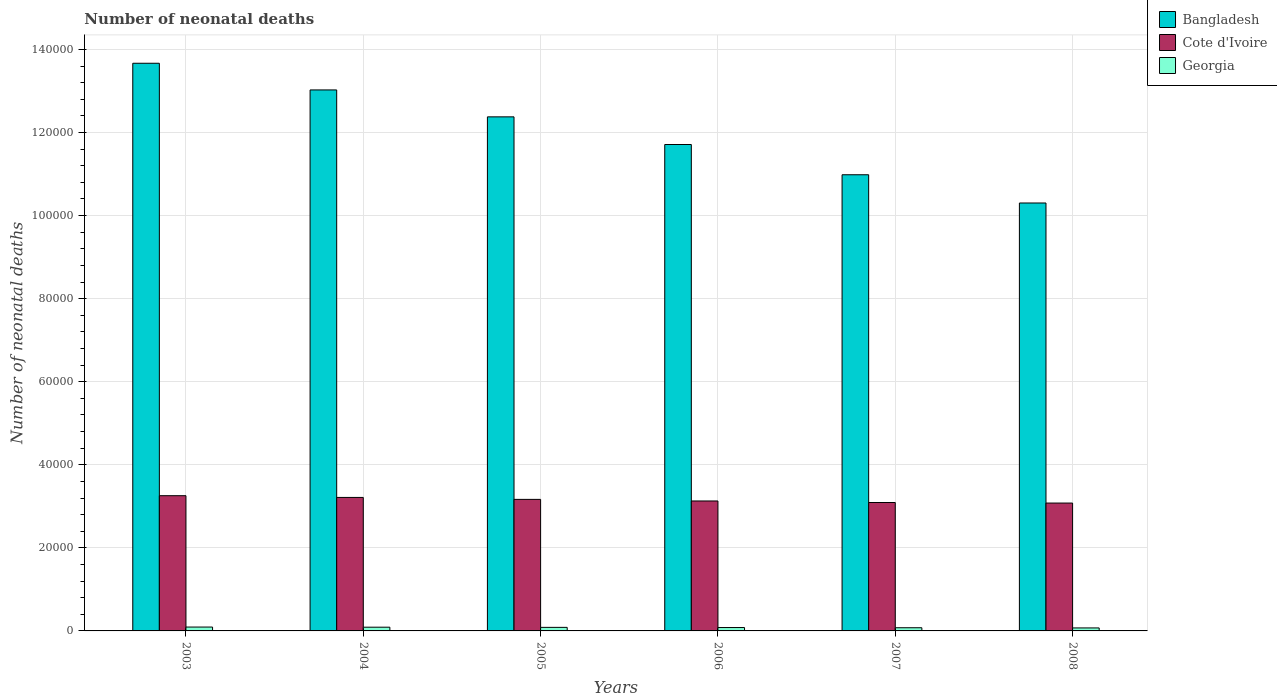How many groups of bars are there?
Provide a short and direct response. 6. Are the number of bars on each tick of the X-axis equal?
Offer a terse response. Yes. How many bars are there on the 6th tick from the left?
Make the answer very short. 3. How many bars are there on the 4th tick from the right?
Offer a terse response. 3. In how many cases, is the number of bars for a given year not equal to the number of legend labels?
Make the answer very short. 0. What is the number of neonatal deaths in in Georgia in 2006?
Your answer should be compact. 814. Across all years, what is the maximum number of neonatal deaths in in Bangladesh?
Your answer should be compact. 1.37e+05. Across all years, what is the minimum number of neonatal deaths in in Georgia?
Your response must be concise. 720. What is the total number of neonatal deaths in in Bangladesh in the graph?
Provide a short and direct response. 7.21e+05. What is the difference between the number of neonatal deaths in in Georgia in 2005 and that in 2007?
Your response must be concise. 89. What is the difference between the number of neonatal deaths in in Georgia in 2006 and the number of neonatal deaths in in Bangladesh in 2004?
Provide a short and direct response. -1.29e+05. What is the average number of neonatal deaths in in Georgia per year?
Provide a succinct answer. 830.67. In the year 2005, what is the difference between the number of neonatal deaths in in Bangladesh and number of neonatal deaths in in Cote d'Ivoire?
Give a very brief answer. 9.21e+04. In how many years, is the number of neonatal deaths in in Cote d'Ivoire greater than 20000?
Provide a succinct answer. 6. What is the ratio of the number of neonatal deaths in in Bangladesh in 2006 to that in 2008?
Keep it short and to the point. 1.14. What is the difference between the highest and the lowest number of neonatal deaths in in Cote d'Ivoire?
Make the answer very short. 1772. What does the 2nd bar from the left in 2006 represents?
Offer a terse response. Cote d'Ivoire. What does the 2nd bar from the right in 2006 represents?
Provide a short and direct response. Cote d'Ivoire. How many bars are there?
Offer a very short reply. 18. Are the values on the major ticks of Y-axis written in scientific E-notation?
Your response must be concise. No. How many legend labels are there?
Offer a terse response. 3. What is the title of the graph?
Your answer should be compact. Number of neonatal deaths. What is the label or title of the X-axis?
Give a very brief answer. Years. What is the label or title of the Y-axis?
Offer a very short reply. Number of neonatal deaths. What is the Number of neonatal deaths of Bangladesh in 2003?
Provide a succinct answer. 1.37e+05. What is the Number of neonatal deaths in Cote d'Ivoire in 2003?
Ensure brevity in your answer.  3.26e+04. What is the Number of neonatal deaths of Georgia in 2003?
Your answer should be compact. 930. What is the Number of neonatal deaths in Bangladesh in 2004?
Give a very brief answer. 1.30e+05. What is the Number of neonatal deaths of Cote d'Ivoire in 2004?
Give a very brief answer. 3.21e+04. What is the Number of neonatal deaths of Georgia in 2004?
Provide a succinct answer. 897. What is the Number of neonatal deaths of Bangladesh in 2005?
Provide a short and direct response. 1.24e+05. What is the Number of neonatal deaths in Cote d'Ivoire in 2005?
Ensure brevity in your answer.  3.17e+04. What is the Number of neonatal deaths of Georgia in 2005?
Provide a succinct answer. 856. What is the Number of neonatal deaths in Bangladesh in 2006?
Ensure brevity in your answer.  1.17e+05. What is the Number of neonatal deaths in Cote d'Ivoire in 2006?
Your answer should be compact. 3.13e+04. What is the Number of neonatal deaths of Georgia in 2006?
Provide a short and direct response. 814. What is the Number of neonatal deaths of Bangladesh in 2007?
Offer a terse response. 1.10e+05. What is the Number of neonatal deaths in Cote d'Ivoire in 2007?
Your response must be concise. 3.09e+04. What is the Number of neonatal deaths in Georgia in 2007?
Keep it short and to the point. 767. What is the Number of neonatal deaths in Bangladesh in 2008?
Ensure brevity in your answer.  1.03e+05. What is the Number of neonatal deaths in Cote d'Ivoire in 2008?
Your answer should be very brief. 3.08e+04. What is the Number of neonatal deaths of Georgia in 2008?
Your response must be concise. 720. Across all years, what is the maximum Number of neonatal deaths in Bangladesh?
Provide a succinct answer. 1.37e+05. Across all years, what is the maximum Number of neonatal deaths in Cote d'Ivoire?
Offer a very short reply. 3.26e+04. Across all years, what is the maximum Number of neonatal deaths of Georgia?
Your response must be concise. 930. Across all years, what is the minimum Number of neonatal deaths of Bangladesh?
Give a very brief answer. 1.03e+05. Across all years, what is the minimum Number of neonatal deaths of Cote d'Ivoire?
Keep it short and to the point. 3.08e+04. Across all years, what is the minimum Number of neonatal deaths of Georgia?
Provide a succinct answer. 720. What is the total Number of neonatal deaths of Bangladesh in the graph?
Keep it short and to the point. 7.21e+05. What is the total Number of neonatal deaths in Cote d'Ivoire in the graph?
Make the answer very short. 1.89e+05. What is the total Number of neonatal deaths in Georgia in the graph?
Your answer should be very brief. 4984. What is the difference between the Number of neonatal deaths in Bangladesh in 2003 and that in 2004?
Provide a succinct answer. 6423. What is the difference between the Number of neonatal deaths in Cote d'Ivoire in 2003 and that in 2004?
Your response must be concise. 420. What is the difference between the Number of neonatal deaths of Georgia in 2003 and that in 2004?
Your answer should be very brief. 33. What is the difference between the Number of neonatal deaths of Bangladesh in 2003 and that in 2005?
Provide a short and direct response. 1.29e+04. What is the difference between the Number of neonatal deaths of Cote d'Ivoire in 2003 and that in 2005?
Offer a very short reply. 888. What is the difference between the Number of neonatal deaths in Bangladesh in 2003 and that in 2006?
Keep it short and to the point. 1.96e+04. What is the difference between the Number of neonatal deaths of Cote d'Ivoire in 2003 and that in 2006?
Your answer should be compact. 1272. What is the difference between the Number of neonatal deaths of Georgia in 2003 and that in 2006?
Keep it short and to the point. 116. What is the difference between the Number of neonatal deaths in Bangladesh in 2003 and that in 2007?
Make the answer very short. 2.68e+04. What is the difference between the Number of neonatal deaths of Cote d'Ivoire in 2003 and that in 2007?
Offer a very short reply. 1642. What is the difference between the Number of neonatal deaths of Georgia in 2003 and that in 2007?
Give a very brief answer. 163. What is the difference between the Number of neonatal deaths of Bangladesh in 2003 and that in 2008?
Provide a succinct answer. 3.36e+04. What is the difference between the Number of neonatal deaths of Cote d'Ivoire in 2003 and that in 2008?
Your response must be concise. 1772. What is the difference between the Number of neonatal deaths of Georgia in 2003 and that in 2008?
Your answer should be very brief. 210. What is the difference between the Number of neonatal deaths of Bangladesh in 2004 and that in 2005?
Your answer should be very brief. 6481. What is the difference between the Number of neonatal deaths in Cote d'Ivoire in 2004 and that in 2005?
Keep it short and to the point. 468. What is the difference between the Number of neonatal deaths of Georgia in 2004 and that in 2005?
Give a very brief answer. 41. What is the difference between the Number of neonatal deaths in Bangladesh in 2004 and that in 2006?
Ensure brevity in your answer.  1.31e+04. What is the difference between the Number of neonatal deaths of Cote d'Ivoire in 2004 and that in 2006?
Offer a terse response. 852. What is the difference between the Number of neonatal deaths of Bangladesh in 2004 and that in 2007?
Your response must be concise. 2.04e+04. What is the difference between the Number of neonatal deaths of Cote d'Ivoire in 2004 and that in 2007?
Your answer should be very brief. 1222. What is the difference between the Number of neonatal deaths in Georgia in 2004 and that in 2007?
Ensure brevity in your answer.  130. What is the difference between the Number of neonatal deaths of Bangladesh in 2004 and that in 2008?
Provide a short and direct response. 2.72e+04. What is the difference between the Number of neonatal deaths of Cote d'Ivoire in 2004 and that in 2008?
Your answer should be very brief. 1352. What is the difference between the Number of neonatal deaths of Georgia in 2004 and that in 2008?
Offer a very short reply. 177. What is the difference between the Number of neonatal deaths in Bangladesh in 2005 and that in 2006?
Offer a very short reply. 6658. What is the difference between the Number of neonatal deaths of Cote d'Ivoire in 2005 and that in 2006?
Give a very brief answer. 384. What is the difference between the Number of neonatal deaths of Bangladesh in 2005 and that in 2007?
Make the answer very short. 1.39e+04. What is the difference between the Number of neonatal deaths in Cote d'Ivoire in 2005 and that in 2007?
Your answer should be compact. 754. What is the difference between the Number of neonatal deaths in Georgia in 2005 and that in 2007?
Offer a terse response. 89. What is the difference between the Number of neonatal deaths of Bangladesh in 2005 and that in 2008?
Ensure brevity in your answer.  2.07e+04. What is the difference between the Number of neonatal deaths of Cote d'Ivoire in 2005 and that in 2008?
Make the answer very short. 884. What is the difference between the Number of neonatal deaths in Georgia in 2005 and that in 2008?
Give a very brief answer. 136. What is the difference between the Number of neonatal deaths in Bangladesh in 2006 and that in 2007?
Offer a terse response. 7283. What is the difference between the Number of neonatal deaths in Cote d'Ivoire in 2006 and that in 2007?
Keep it short and to the point. 370. What is the difference between the Number of neonatal deaths in Bangladesh in 2006 and that in 2008?
Keep it short and to the point. 1.41e+04. What is the difference between the Number of neonatal deaths of Georgia in 2006 and that in 2008?
Your answer should be compact. 94. What is the difference between the Number of neonatal deaths in Bangladesh in 2007 and that in 2008?
Make the answer very short. 6796. What is the difference between the Number of neonatal deaths in Cote d'Ivoire in 2007 and that in 2008?
Make the answer very short. 130. What is the difference between the Number of neonatal deaths of Georgia in 2007 and that in 2008?
Give a very brief answer. 47. What is the difference between the Number of neonatal deaths in Bangladesh in 2003 and the Number of neonatal deaths in Cote d'Ivoire in 2004?
Provide a succinct answer. 1.05e+05. What is the difference between the Number of neonatal deaths in Bangladesh in 2003 and the Number of neonatal deaths in Georgia in 2004?
Your answer should be very brief. 1.36e+05. What is the difference between the Number of neonatal deaths of Cote d'Ivoire in 2003 and the Number of neonatal deaths of Georgia in 2004?
Ensure brevity in your answer.  3.17e+04. What is the difference between the Number of neonatal deaths of Bangladesh in 2003 and the Number of neonatal deaths of Cote d'Ivoire in 2005?
Your answer should be very brief. 1.05e+05. What is the difference between the Number of neonatal deaths in Bangladesh in 2003 and the Number of neonatal deaths in Georgia in 2005?
Your answer should be compact. 1.36e+05. What is the difference between the Number of neonatal deaths of Cote d'Ivoire in 2003 and the Number of neonatal deaths of Georgia in 2005?
Offer a terse response. 3.17e+04. What is the difference between the Number of neonatal deaths of Bangladesh in 2003 and the Number of neonatal deaths of Cote d'Ivoire in 2006?
Offer a terse response. 1.05e+05. What is the difference between the Number of neonatal deaths of Bangladesh in 2003 and the Number of neonatal deaths of Georgia in 2006?
Offer a very short reply. 1.36e+05. What is the difference between the Number of neonatal deaths of Cote d'Ivoire in 2003 and the Number of neonatal deaths of Georgia in 2006?
Provide a short and direct response. 3.17e+04. What is the difference between the Number of neonatal deaths in Bangladesh in 2003 and the Number of neonatal deaths in Cote d'Ivoire in 2007?
Offer a terse response. 1.06e+05. What is the difference between the Number of neonatal deaths in Bangladesh in 2003 and the Number of neonatal deaths in Georgia in 2007?
Keep it short and to the point. 1.36e+05. What is the difference between the Number of neonatal deaths of Cote d'Ivoire in 2003 and the Number of neonatal deaths of Georgia in 2007?
Your response must be concise. 3.18e+04. What is the difference between the Number of neonatal deaths in Bangladesh in 2003 and the Number of neonatal deaths in Cote d'Ivoire in 2008?
Your answer should be very brief. 1.06e+05. What is the difference between the Number of neonatal deaths in Bangladesh in 2003 and the Number of neonatal deaths in Georgia in 2008?
Give a very brief answer. 1.36e+05. What is the difference between the Number of neonatal deaths of Cote d'Ivoire in 2003 and the Number of neonatal deaths of Georgia in 2008?
Offer a terse response. 3.18e+04. What is the difference between the Number of neonatal deaths of Bangladesh in 2004 and the Number of neonatal deaths of Cote d'Ivoire in 2005?
Make the answer very short. 9.86e+04. What is the difference between the Number of neonatal deaths of Bangladesh in 2004 and the Number of neonatal deaths of Georgia in 2005?
Offer a terse response. 1.29e+05. What is the difference between the Number of neonatal deaths in Cote d'Ivoire in 2004 and the Number of neonatal deaths in Georgia in 2005?
Provide a succinct answer. 3.13e+04. What is the difference between the Number of neonatal deaths in Bangladesh in 2004 and the Number of neonatal deaths in Cote d'Ivoire in 2006?
Keep it short and to the point. 9.90e+04. What is the difference between the Number of neonatal deaths in Bangladesh in 2004 and the Number of neonatal deaths in Georgia in 2006?
Keep it short and to the point. 1.29e+05. What is the difference between the Number of neonatal deaths in Cote d'Ivoire in 2004 and the Number of neonatal deaths in Georgia in 2006?
Provide a succinct answer. 3.13e+04. What is the difference between the Number of neonatal deaths of Bangladesh in 2004 and the Number of neonatal deaths of Cote d'Ivoire in 2007?
Give a very brief answer. 9.93e+04. What is the difference between the Number of neonatal deaths of Bangladesh in 2004 and the Number of neonatal deaths of Georgia in 2007?
Offer a very short reply. 1.29e+05. What is the difference between the Number of neonatal deaths of Cote d'Ivoire in 2004 and the Number of neonatal deaths of Georgia in 2007?
Ensure brevity in your answer.  3.14e+04. What is the difference between the Number of neonatal deaths of Bangladesh in 2004 and the Number of neonatal deaths of Cote d'Ivoire in 2008?
Your response must be concise. 9.95e+04. What is the difference between the Number of neonatal deaths in Bangladesh in 2004 and the Number of neonatal deaths in Georgia in 2008?
Offer a terse response. 1.30e+05. What is the difference between the Number of neonatal deaths of Cote d'Ivoire in 2004 and the Number of neonatal deaths of Georgia in 2008?
Provide a short and direct response. 3.14e+04. What is the difference between the Number of neonatal deaths of Bangladesh in 2005 and the Number of neonatal deaths of Cote d'Ivoire in 2006?
Your answer should be compact. 9.25e+04. What is the difference between the Number of neonatal deaths of Bangladesh in 2005 and the Number of neonatal deaths of Georgia in 2006?
Your answer should be very brief. 1.23e+05. What is the difference between the Number of neonatal deaths in Cote d'Ivoire in 2005 and the Number of neonatal deaths in Georgia in 2006?
Make the answer very short. 3.09e+04. What is the difference between the Number of neonatal deaths in Bangladesh in 2005 and the Number of neonatal deaths in Cote d'Ivoire in 2007?
Make the answer very short. 9.28e+04. What is the difference between the Number of neonatal deaths of Bangladesh in 2005 and the Number of neonatal deaths of Georgia in 2007?
Make the answer very short. 1.23e+05. What is the difference between the Number of neonatal deaths in Cote d'Ivoire in 2005 and the Number of neonatal deaths in Georgia in 2007?
Provide a short and direct response. 3.09e+04. What is the difference between the Number of neonatal deaths of Bangladesh in 2005 and the Number of neonatal deaths of Cote d'Ivoire in 2008?
Make the answer very short. 9.30e+04. What is the difference between the Number of neonatal deaths of Bangladesh in 2005 and the Number of neonatal deaths of Georgia in 2008?
Ensure brevity in your answer.  1.23e+05. What is the difference between the Number of neonatal deaths of Cote d'Ivoire in 2005 and the Number of neonatal deaths of Georgia in 2008?
Provide a short and direct response. 3.10e+04. What is the difference between the Number of neonatal deaths of Bangladesh in 2006 and the Number of neonatal deaths of Cote d'Ivoire in 2007?
Provide a succinct answer. 8.62e+04. What is the difference between the Number of neonatal deaths of Bangladesh in 2006 and the Number of neonatal deaths of Georgia in 2007?
Provide a succinct answer. 1.16e+05. What is the difference between the Number of neonatal deaths of Cote d'Ivoire in 2006 and the Number of neonatal deaths of Georgia in 2007?
Make the answer very short. 3.05e+04. What is the difference between the Number of neonatal deaths of Bangladesh in 2006 and the Number of neonatal deaths of Cote d'Ivoire in 2008?
Make the answer very short. 8.63e+04. What is the difference between the Number of neonatal deaths in Bangladesh in 2006 and the Number of neonatal deaths in Georgia in 2008?
Keep it short and to the point. 1.16e+05. What is the difference between the Number of neonatal deaths of Cote d'Ivoire in 2006 and the Number of neonatal deaths of Georgia in 2008?
Provide a short and direct response. 3.06e+04. What is the difference between the Number of neonatal deaths of Bangladesh in 2007 and the Number of neonatal deaths of Cote d'Ivoire in 2008?
Provide a short and direct response. 7.90e+04. What is the difference between the Number of neonatal deaths in Bangladesh in 2007 and the Number of neonatal deaths in Georgia in 2008?
Ensure brevity in your answer.  1.09e+05. What is the difference between the Number of neonatal deaths of Cote d'Ivoire in 2007 and the Number of neonatal deaths of Georgia in 2008?
Make the answer very short. 3.02e+04. What is the average Number of neonatal deaths of Bangladesh per year?
Your answer should be compact. 1.20e+05. What is the average Number of neonatal deaths in Cote d'Ivoire per year?
Make the answer very short. 3.16e+04. What is the average Number of neonatal deaths of Georgia per year?
Keep it short and to the point. 830.67. In the year 2003, what is the difference between the Number of neonatal deaths in Bangladesh and Number of neonatal deaths in Cote d'Ivoire?
Give a very brief answer. 1.04e+05. In the year 2003, what is the difference between the Number of neonatal deaths of Bangladesh and Number of neonatal deaths of Georgia?
Your answer should be very brief. 1.36e+05. In the year 2003, what is the difference between the Number of neonatal deaths in Cote d'Ivoire and Number of neonatal deaths in Georgia?
Give a very brief answer. 3.16e+04. In the year 2004, what is the difference between the Number of neonatal deaths in Bangladesh and Number of neonatal deaths in Cote d'Ivoire?
Provide a succinct answer. 9.81e+04. In the year 2004, what is the difference between the Number of neonatal deaths of Bangladesh and Number of neonatal deaths of Georgia?
Provide a short and direct response. 1.29e+05. In the year 2004, what is the difference between the Number of neonatal deaths in Cote d'Ivoire and Number of neonatal deaths in Georgia?
Give a very brief answer. 3.12e+04. In the year 2005, what is the difference between the Number of neonatal deaths of Bangladesh and Number of neonatal deaths of Cote d'Ivoire?
Offer a very short reply. 9.21e+04. In the year 2005, what is the difference between the Number of neonatal deaths in Bangladesh and Number of neonatal deaths in Georgia?
Make the answer very short. 1.23e+05. In the year 2005, what is the difference between the Number of neonatal deaths in Cote d'Ivoire and Number of neonatal deaths in Georgia?
Your response must be concise. 3.08e+04. In the year 2006, what is the difference between the Number of neonatal deaths in Bangladesh and Number of neonatal deaths in Cote d'Ivoire?
Provide a short and direct response. 8.58e+04. In the year 2006, what is the difference between the Number of neonatal deaths in Bangladesh and Number of neonatal deaths in Georgia?
Keep it short and to the point. 1.16e+05. In the year 2006, what is the difference between the Number of neonatal deaths of Cote d'Ivoire and Number of neonatal deaths of Georgia?
Provide a succinct answer. 3.05e+04. In the year 2007, what is the difference between the Number of neonatal deaths of Bangladesh and Number of neonatal deaths of Cote d'Ivoire?
Provide a short and direct response. 7.89e+04. In the year 2007, what is the difference between the Number of neonatal deaths in Bangladesh and Number of neonatal deaths in Georgia?
Provide a succinct answer. 1.09e+05. In the year 2007, what is the difference between the Number of neonatal deaths in Cote d'Ivoire and Number of neonatal deaths in Georgia?
Offer a terse response. 3.01e+04. In the year 2008, what is the difference between the Number of neonatal deaths in Bangladesh and Number of neonatal deaths in Cote d'Ivoire?
Give a very brief answer. 7.22e+04. In the year 2008, what is the difference between the Number of neonatal deaths in Bangladesh and Number of neonatal deaths in Georgia?
Give a very brief answer. 1.02e+05. In the year 2008, what is the difference between the Number of neonatal deaths of Cote d'Ivoire and Number of neonatal deaths of Georgia?
Your response must be concise. 3.01e+04. What is the ratio of the Number of neonatal deaths in Bangladesh in 2003 to that in 2004?
Your answer should be very brief. 1.05. What is the ratio of the Number of neonatal deaths in Cote d'Ivoire in 2003 to that in 2004?
Offer a very short reply. 1.01. What is the ratio of the Number of neonatal deaths in Georgia in 2003 to that in 2004?
Your answer should be very brief. 1.04. What is the ratio of the Number of neonatal deaths of Bangladesh in 2003 to that in 2005?
Make the answer very short. 1.1. What is the ratio of the Number of neonatal deaths in Cote d'Ivoire in 2003 to that in 2005?
Your answer should be compact. 1.03. What is the ratio of the Number of neonatal deaths in Georgia in 2003 to that in 2005?
Provide a short and direct response. 1.09. What is the ratio of the Number of neonatal deaths in Bangladesh in 2003 to that in 2006?
Provide a short and direct response. 1.17. What is the ratio of the Number of neonatal deaths of Cote d'Ivoire in 2003 to that in 2006?
Your answer should be very brief. 1.04. What is the ratio of the Number of neonatal deaths of Georgia in 2003 to that in 2006?
Ensure brevity in your answer.  1.14. What is the ratio of the Number of neonatal deaths in Bangladesh in 2003 to that in 2007?
Ensure brevity in your answer.  1.24. What is the ratio of the Number of neonatal deaths in Cote d'Ivoire in 2003 to that in 2007?
Make the answer very short. 1.05. What is the ratio of the Number of neonatal deaths in Georgia in 2003 to that in 2007?
Offer a terse response. 1.21. What is the ratio of the Number of neonatal deaths of Bangladesh in 2003 to that in 2008?
Ensure brevity in your answer.  1.33. What is the ratio of the Number of neonatal deaths in Cote d'Ivoire in 2003 to that in 2008?
Keep it short and to the point. 1.06. What is the ratio of the Number of neonatal deaths in Georgia in 2003 to that in 2008?
Your answer should be very brief. 1.29. What is the ratio of the Number of neonatal deaths of Bangladesh in 2004 to that in 2005?
Ensure brevity in your answer.  1.05. What is the ratio of the Number of neonatal deaths in Cote d'Ivoire in 2004 to that in 2005?
Ensure brevity in your answer.  1.01. What is the ratio of the Number of neonatal deaths of Georgia in 2004 to that in 2005?
Your response must be concise. 1.05. What is the ratio of the Number of neonatal deaths in Bangladesh in 2004 to that in 2006?
Give a very brief answer. 1.11. What is the ratio of the Number of neonatal deaths of Cote d'Ivoire in 2004 to that in 2006?
Your answer should be compact. 1.03. What is the ratio of the Number of neonatal deaths of Georgia in 2004 to that in 2006?
Ensure brevity in your answer.  1.1. What is the ratio of the Number of neonatal deaths in Bangladesh in 2004 to that in 2007?
Keep it short and to the point. 1.19. What is the ratio of the Number of neonatal deaths in Cote d'Ivoire in 2004 to that in 2007?
Your answer should be very brief. 1.04. What is the ratio of the Number of neonatal deaths of Georgia in 2004 to that in 2007?
Your answer should be compact. 1.17. What is the ratio of the Number of neonatal deaths in Bangladesh in 2004 to that in 2008?
Your answer should be compact. 1.26. What is the ratio of the Number of neonatal deaths in Cote d'Ivoire in 2004 to that in 2008?
Provide a short and direct response. 1.04. What is the ratio of the Number of neonatal deaths in Georgia in 2004 to that in 2008?
Keep it short and to the point. 1.25. What is the ratio of the Number of neonatal deaths of Bangladesh in 2005 to that in 2006?
Make the answer very short. 1.06. What is the ratio of the Number of neonatal deaths of Cote d'Ivoire in 2005 to that in 2006?
Give a very brief answer. 1.01. What is the ratio of the Number of neonatal deaths in Georgia in 2005 to that in 2006?
Make the answer very short. 1.05. What is the ratio of the Number of neonatal deaths of Bangladesh in 2005 to that in 2007?
Offer a very short reply. 1.13. What is the ratio of the Number of neonatal deaths in Cote d'Ivoire in 2005 to that in 2007?
Offer a very short reply. 1.02. What is the ratio of the Number of neonatal deaths in Georgia in 2005 to that in 2007?
Provide a succinct answer. 1.12. What is the ratio of the Number of neonatal deaths of Bangladesh in 2005 to that in 2008?
Ensure brevity in your answer.  1.2. What is the ratio of the Number of neonatal deaths of Cote d'Ivoire in 2005 to that in 2008?
Provide a succinct answer. 1.03. What is the ratio of the Number of neonatal deaths of Georgia in 2005 to that in 2008?
Give a very brief answer. 1.19. What is the ratio of the Number of neonatal deaths in Bangladesh in 2006 to that in 2007?
Your answer should be very brief. 1.07. What is the ratio of the Number of neonatal deaths in Georgia in 2006 to that in 2007?
Your answer should be very brief. 1.06. What is the ratio of the Number of neonatal deaths in Bangladesh in 2006 to that in 2008?
Make the answer very short. 1.14. What is the ratio of the Number of neonatal deaths in Cote d'Ivoire in 2006 to that in 2008?
Keep it short and to the point. 1.02. What is the ratio of the Number of neonatal deaths of Georgia in 2006 to that in 2008?
Your answer should be compact. 1.13. What is the ratio of the Number of neonatal deaths of Bangladesh in 2007 to that in 2008?
Keep it short and to the point. 1.07. What is the ratio of the Number of neonatal deaths in Cote d'Ivoire in 2007 to that in 2008?
Provide a succinct answer. 1. What is the ratio of the Number of neonatal deaths of Georgia in 2007 to that in 2008?
Make the answer very short. 1.07. What is the difference between the highest and the second highest Number of neonatal deaths of Bangladesh?
Ensure brevity in your answer.  6423. What is the difference between the highest and the second highest Number of neonatal deaths in Cote d'Ivoire?
Your response must be concise. 420. What is the difference between the highest and the lowest Number of neonatal deaths in Bangladesh?
Offer a very short reply. 3.36e+04. What is the difference between the highest and the lowest Number of neonatal deaths of Cote d'Ivoire?
Your response must be concise. 1772. What is the difference between the highest and the lowest Number of neonatal deaths in Georgia?
Offer a very short reply. 210. 